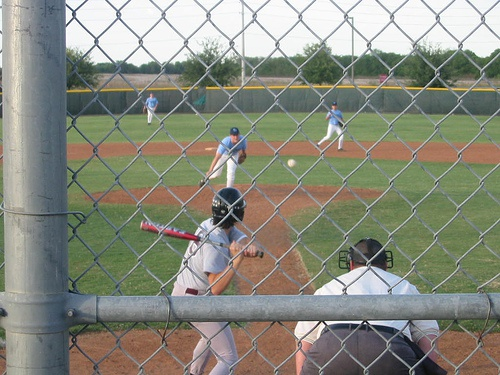Describe the objects in this image and their specific colors. I can see people in white, gray, lightgray, black, and darkgray tones, people in white, darkgray, lightgray, gray, and black tones, people in white, lightgray, darkgray, gray, and tan tones, people in white, lightgray, darkgray, and gray tones, and baseball bat in white, darkgray, brown, gray, and salmon tones in this image. 